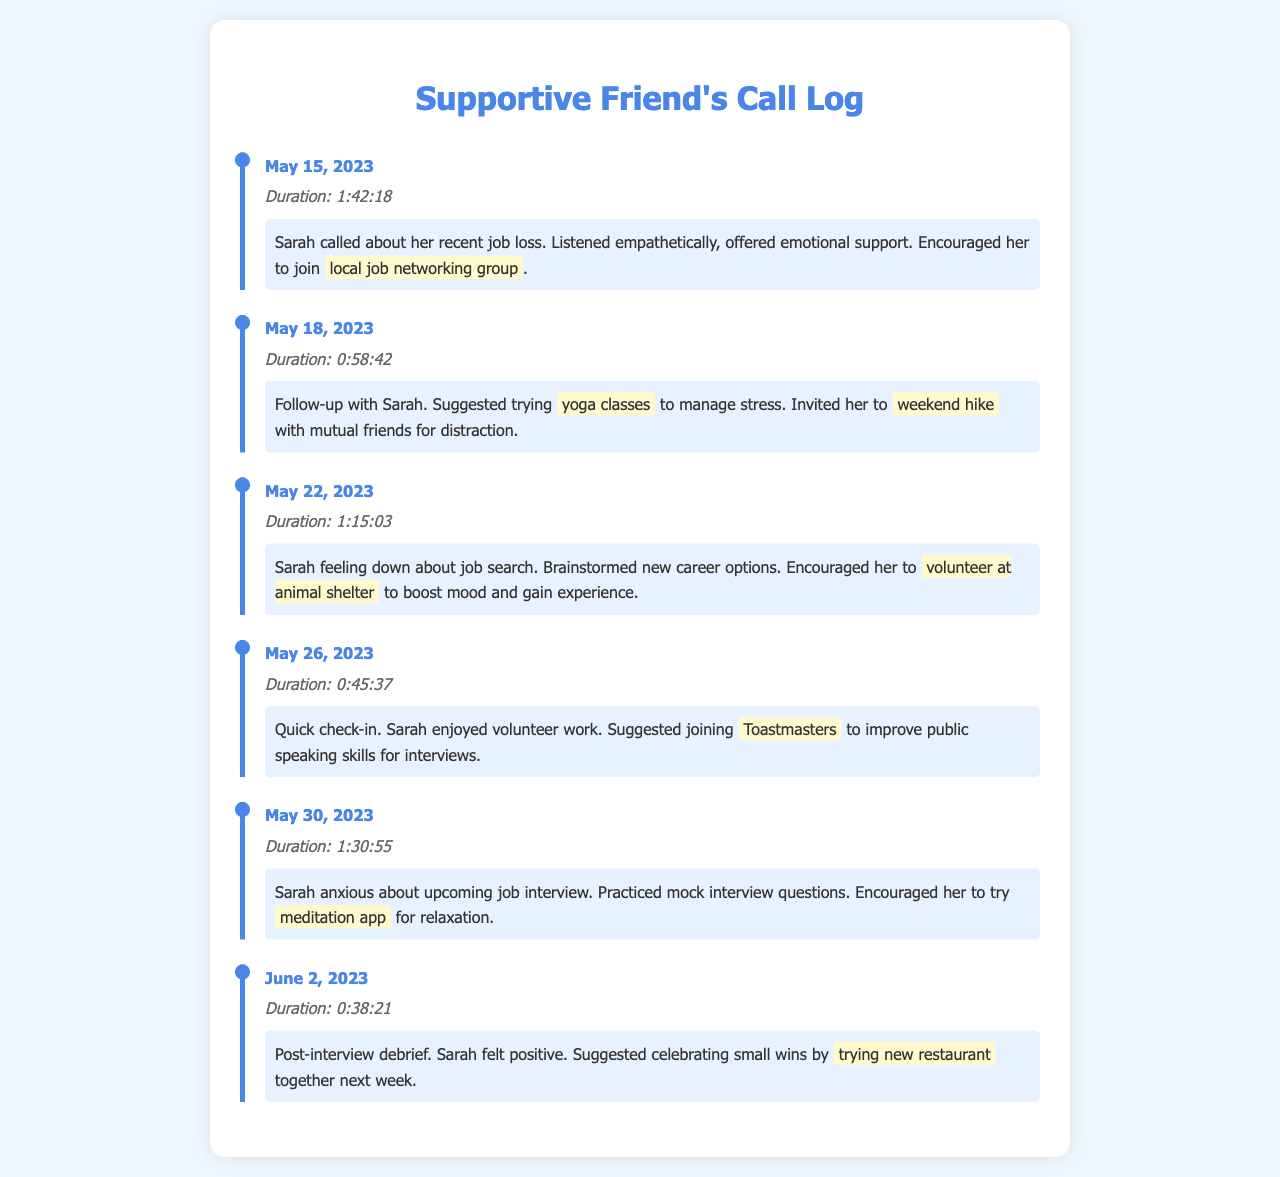What was the duration of the first call? The duration of the first call on May 15, 2023, is listed as 1:42:18.
Answer: 1:42:18 What emotional support did Sarah receive during her job loss? Sarah received emotional support and was encouraged to join a local job networking group.
Answer: local job networking group On which date did Sarah feel positive after her interview? The date of the post-interview debrief when Sarah felt positive is June 2, 2023.
Answer: June 2, 2023 What new activity was suggested to Sarah on May 22, 2023? On this date, Sarah was encouraged to volunteer at an animal shelter to boost her mood and gain experience.
Answer: volunteer at animal shelter How many calls were made in total? The document includes information on six individual calls made to Sarah.
Answer: 6 What was the last activity suggested to Sarah in the logs? The last activity suggested was trying a new restaurant together next week following her positive interview feedback.
Answer: trying new restaurant 